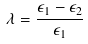<formula> <loc_0><loc_0><loc_500><loc_500>\lambda = \frac { \epsilon _ { 1 } - \epsilon _ { 2 } } { \epsilon _ { 1 } }</formula> 